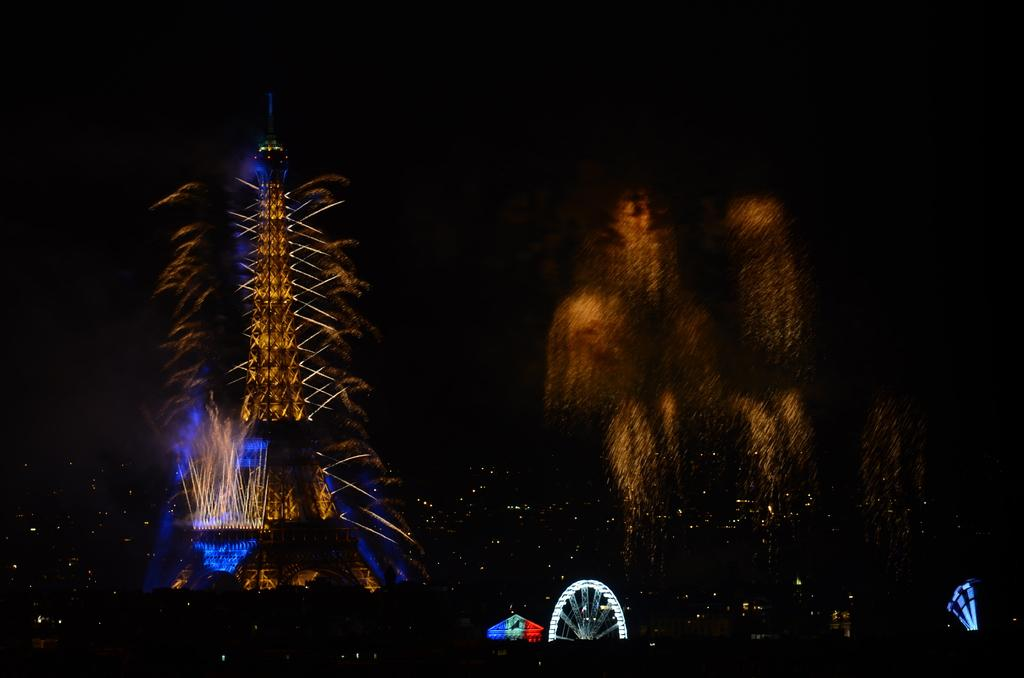What famous landmark is present in the image? The Eiffel tower is present in the image with lights. What other structure can be seen at the bottom of the image? There is a giant wheel with lights at the bottom of the image. What additional visual element is present in the image? Fireworks are visible in the image. How would you describe the overall lighting conditions in the image? The background of the image is dark. Can you tell me how many frogs are sitting on the Eiffel tower in the image? There are no frogs present on the Eiffel tower in the image. Is there a person visible in the image? The provided facts do not mention any person in the image. 